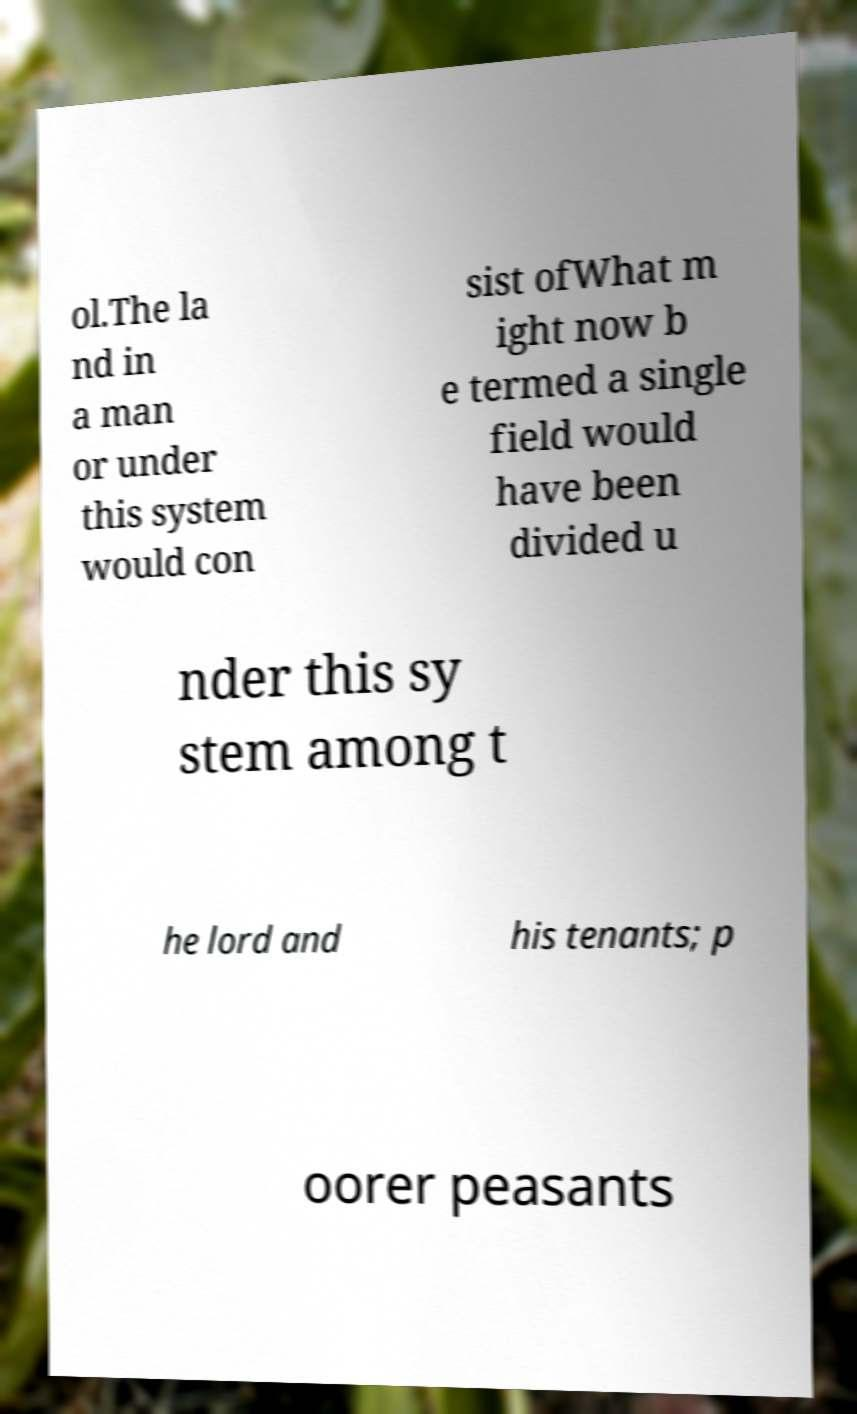For documentation purposes, I need the text within this image transcribed. Could you provide that? ol.The la nd in a man or under this system would con sist ofWhat m ight now b e termed a single field would have been divided u nder this sy stem among t he lord and his tenants; p oorer peasants 